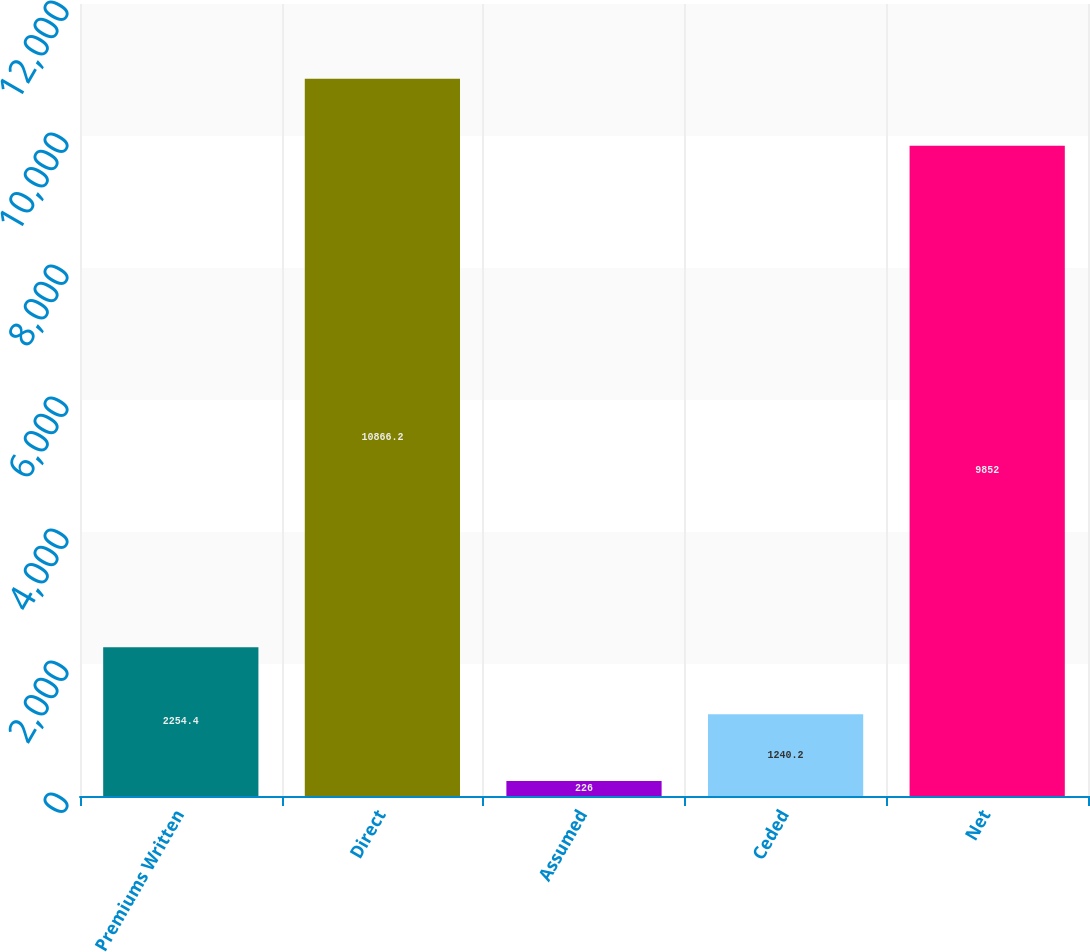Convert chart to OTSL. <chart><loc_0><loc_0><loc_500><loc_500><bar_chart><fcel>Premiums Written<fcel>Direct<fcel>Assumed<fcel>Ceded<fcel>Net<nl><fcel>2254.4<fcel>10866.2<fcel>226<fcel>1240.2<fcel>9852<nl></chart> 